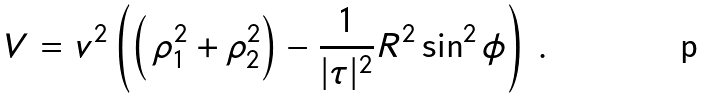Convert formula to latex. <formula><loc_0><loc_0><loc_500><loc_500>V = v ^ { 2 } \left ( \left ( \, \rho _ { 1 } ^ { 2 } + \rho _ { 2 } ^ { 2 } \right ) - \frac { 1 } { | \tau | ^ { 2 } } R ^ { 2 } \sin ^ { 2 } \phi \right ) \, .</formula> 